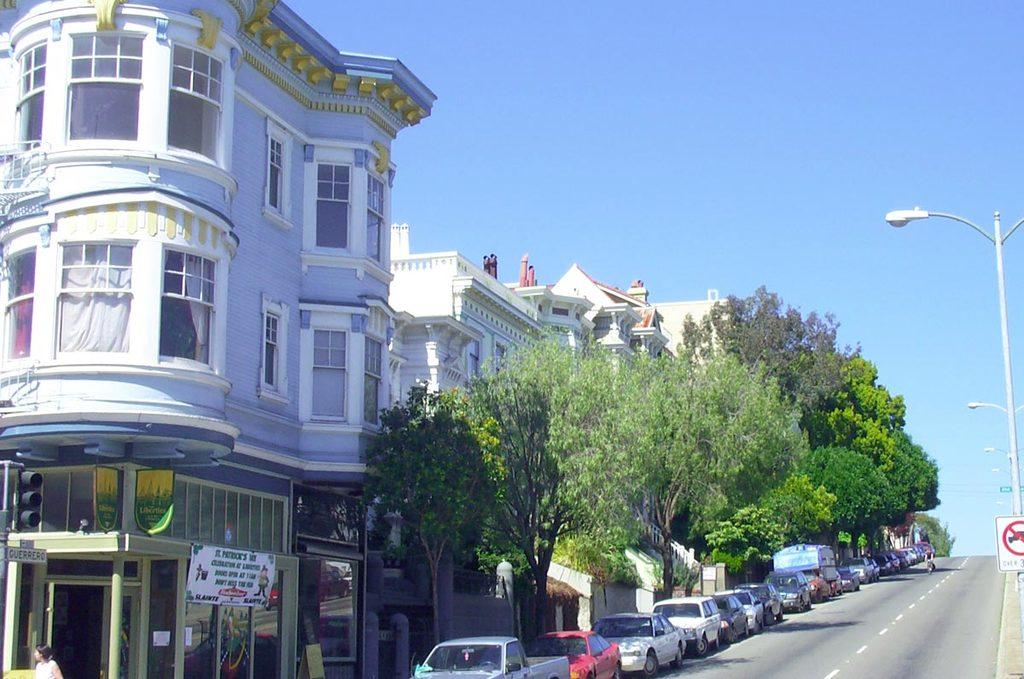What type of structures can be seen in the image? There are many buildings in the image. What other elements can be seen in the image besides buildings? There are trees and cars parked on the road in the image. Are there any utility structures visible in the image? Yes, there are electric poles in the image. What role does the sister play in the army in the image? There is no mention of a sister or an army in the image. The image primarily features buildings, trees, cars, and electric poles. 